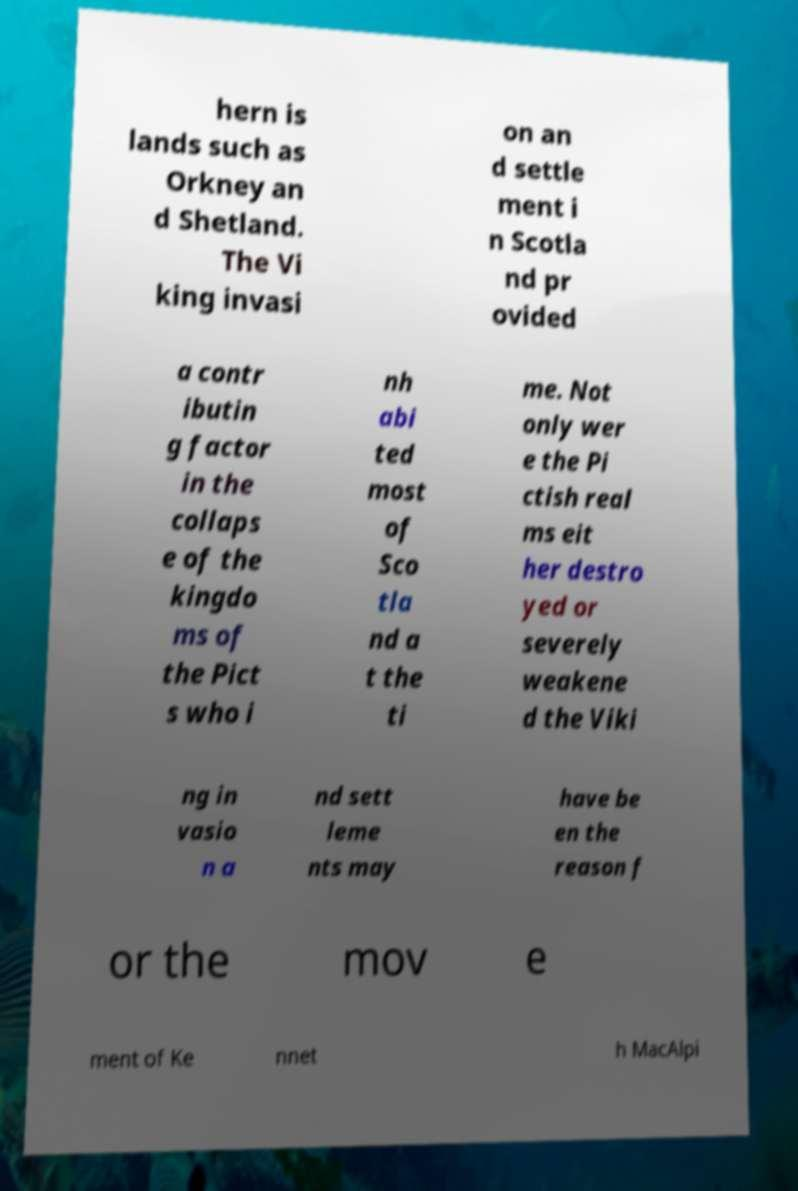Please read and relay the text visible in this image. What does it say? hern is lands such as Orkney an d Shetland. The Vi king invasi on an d settle ment i n Scotla nd pr ovided a contr ibutin g factor in the collaps e of the kingdo ms of the Pict s who i nh abi ted most of Sco tla nd a t the ti me. Not only wer e the Pi ctish real ms eit her destro yed or severely weakene d the Viki ng in vasio n a nd sett leme nts may have be en the reason f or the mov e ment of Ke nnet h MacAlpi 